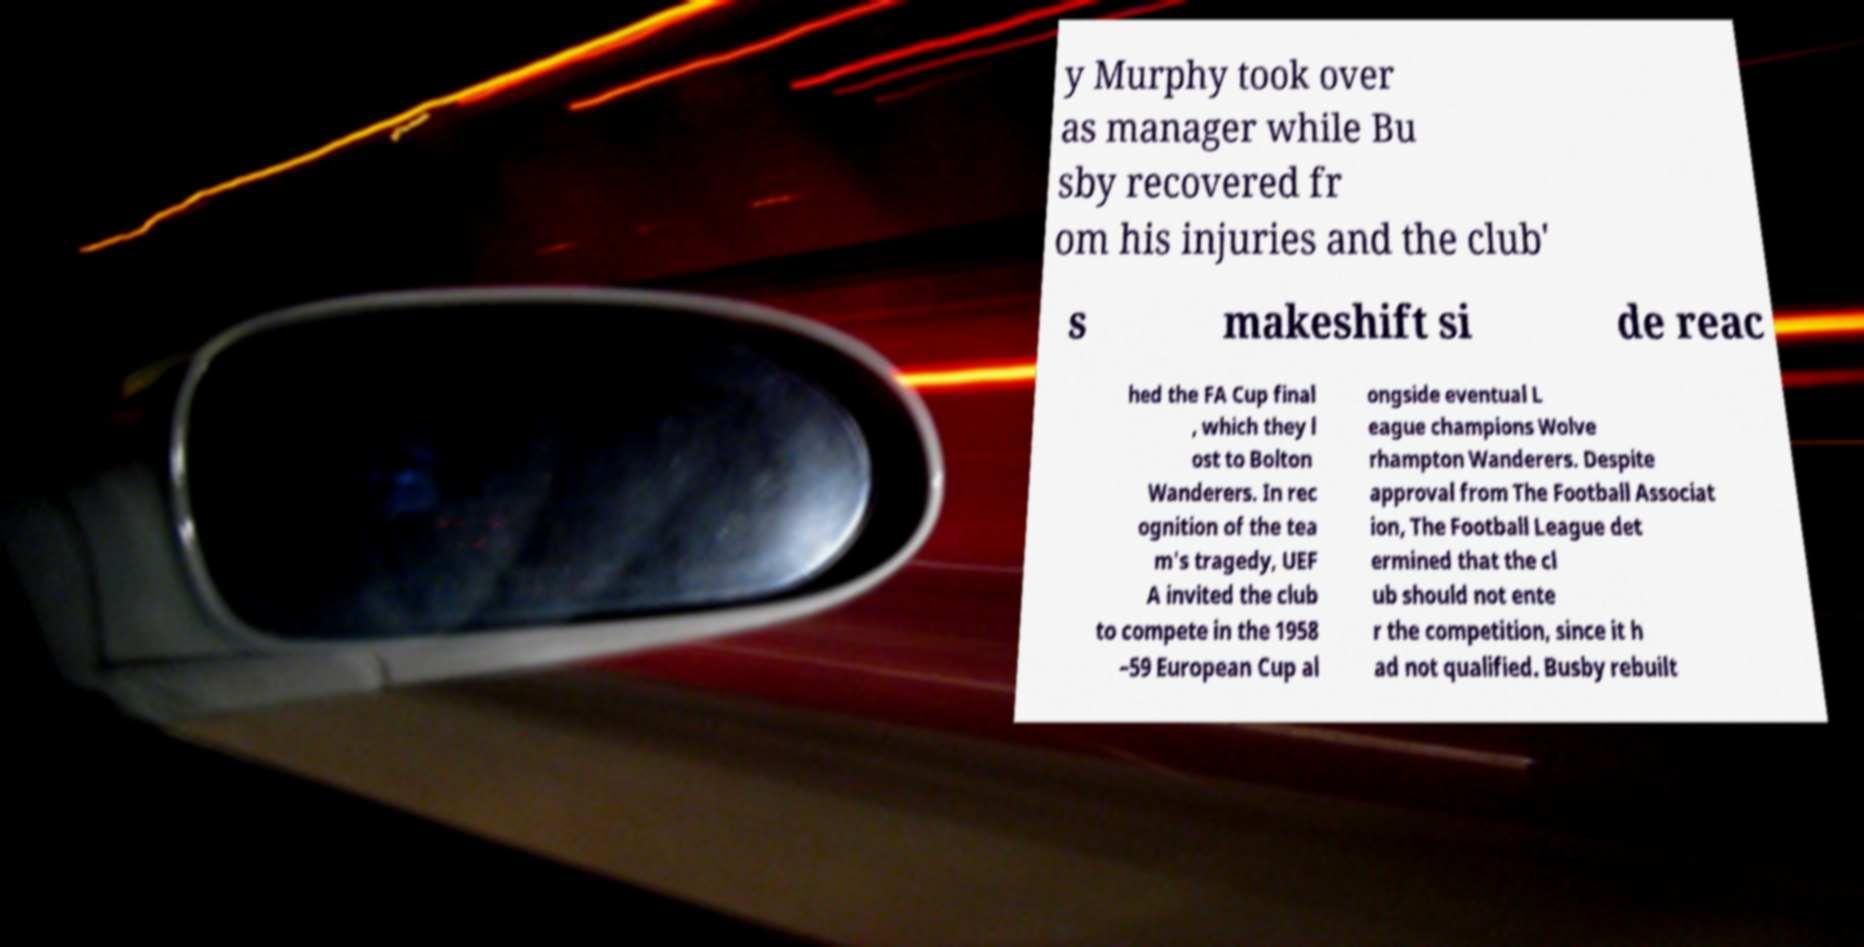I need the written content from this picture converted into text. Can you do that? y Murphy took over as manager while Bu sby recovered fr om his injuries and the club' s makeshift si de reac hed the FA Cup final , which they l ost to Bolton Wanderers. In rec ognition of the tea m's tragedy, UEF A invited the club to compete in the 1958 –59 European Cup al ongside eventual L eague champions Wolve rhampton Wanderers. Despite approval from The Football Associat ion, The Football League det ermined that the cl ub should not ente r the competition, since it h ad not qualified. Busby rebuilt 